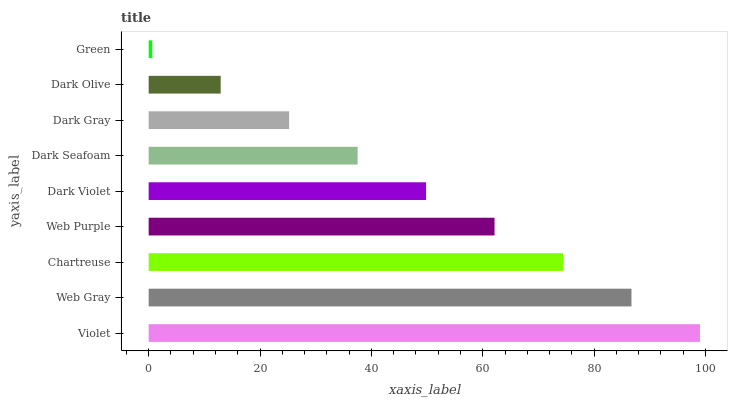Is Green the minimum?
Answer yes or no. Yes. Is Violet the maximum?
Answer yes or no. Yes. Is Web Gray the minimum?
Answer yes or no. No. Is Web Gray the maximum?
Answer yes or no. No. Is Violet greater than Web Gray?
Answer yes or no. Yes. Is Web Gray less than Violet?
Answer yes or no. Yes. Is Web Gray greater than Violet?
Answer yes or no. No. Is Violet less than Web Gray?
Answer yes or no. No. Is Dark Violet the high median?
Answer yes or no. Yes. Is Dark Violet the low median?
Answer yes or no. Yes. Is Chartreuse the high median?
Answer yes or no. No. Is Dark Olive the low median?
Answer yes or no. No. 